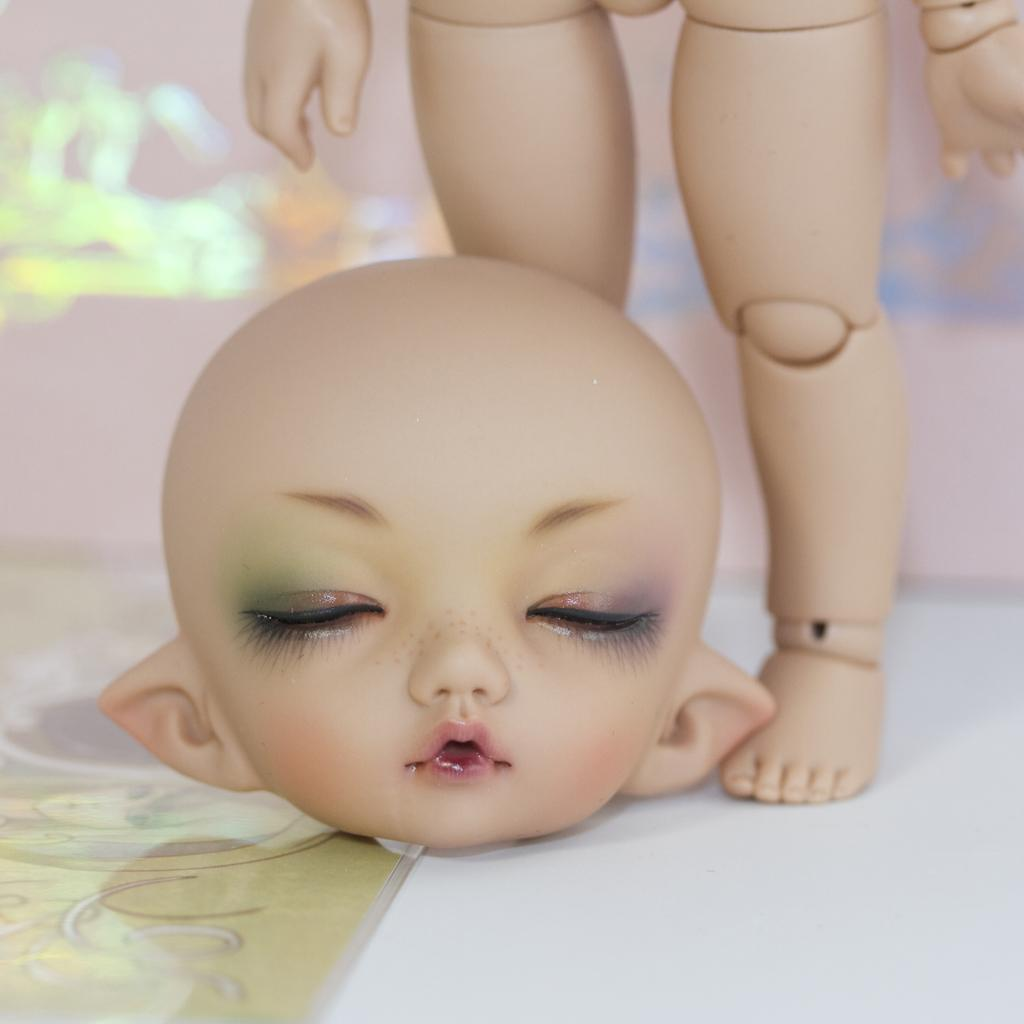What object in the image is designed for play or entertainment? There is a toy in the image. What type of fireman is depicted on the toy in the image? There is no fireman depicted on the toy in the image. 